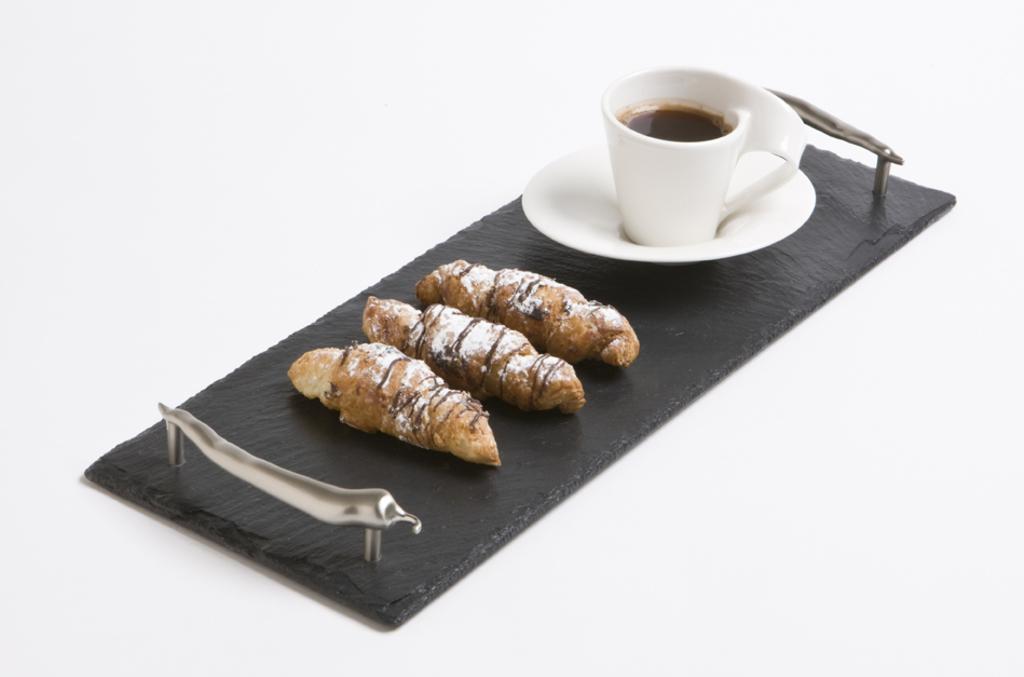In one or two sentences, can you explain what this image depicts? In this image we can see a tray with some food items. And we can see a saucer and cup with drink. 